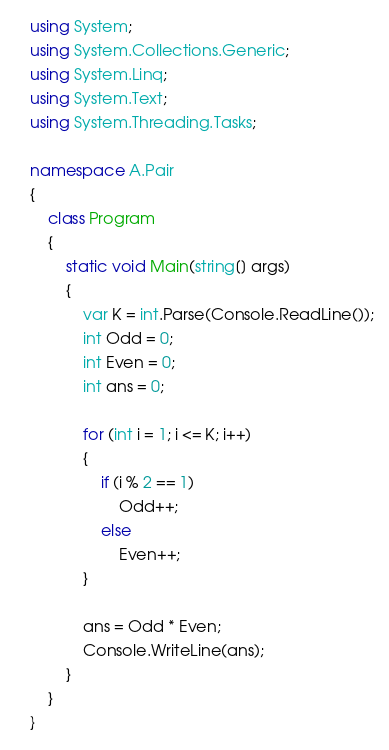<code> <loc_0><loc_0><loc_500><loc_500><_C#_>using System;
using System.Collections.Generic;
using System.Linq;
using System.Text;
using System.Threading.Tasks;

namespace A.Pair
{
    class Program
    {
        static void Main(string[] args)
        {
            var K = int.Parse(Console.ReadLine());
            int Odd = 0;
            int Even = 0;
            int ans = 0;

            for (int i = 1; i <= K; i++)
            {
                if (i % 2 == 1)
                    Odd++;
                else
                    Even++;
            }

            ans = Odd * Even;
            Console.WriteLine(ans);
        }
    }
}</code> 